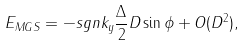<formula> <loc_0><loc_0><loc_500><loc_500>E _ { M G S } = - s g n k _ { y } \frac { \Delta } { 2 } D \sin \phi + O ( D ^ { 2 } ) ,</formula> 